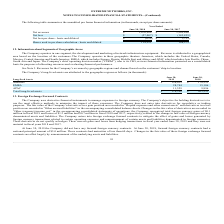From Extreme Networks's financial document, What does the region of Americas include? The document contains multiple relevant values: United States, Canada, Mexico, Central America, South America. From the document: "nited States, Canada, Mexico, Central America and South America; EMEA, which includes Europe, Russia, Middle East and Africa; and APAC which includes ..." Also, Which years does the table provide information for the company's long-lived assets are attributed to the geographic regions? The document shows two values: 2019 and 2018. From the document: "2019 June 30, 2018 June 30, 2017..." Also, What was the amount of Total long-lived assets in 2019? According to the financial document, 176,308 (in thousands). The relevant text states: "Total long-lived assets $ 176,308 $ 203,253..." Also, How many years did long-lived assets from Americas exceed $150,000 thousand? Based on the analysis, there are 1 instances. The counting process: 2018. Also, can you calculate: What was the change in the long-lived assets from APAC between 2018 and 2019? Based on the calculation: 11,529-9,896, the result is 1633 (in thousands). This is based on the information: "APAC 11,529 9,896 APAC 11,529 9,896..." The key data points involved are: 11,529, 9,896. Also, can you calculate: What was the percentage change in total long-lived assets between 2018 and 2019? To answer this question, I need to perform calculations using the financial data. The calculation is: (176,308-203,253)/203,253, which equals -13.26 (percentage). This is based on the information: "Total long-lived assets $ 176,308 $ 203,253 Total long-lived assets $ 176,308 $ 203,253..." The key data points involved are: 176,308, 203,253. 